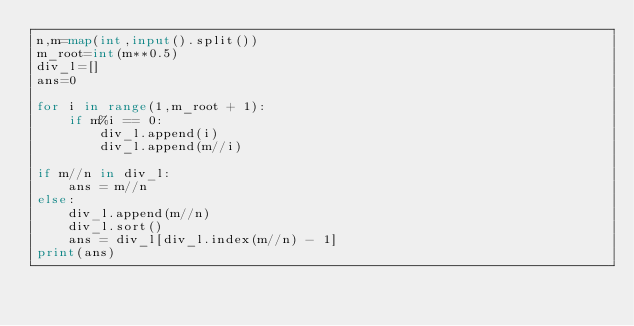Convert code to text. <code><loc_0><loc_0><loc_500><loc_500><_Python_>n,m=map(int,input().split())
m_root=int(m**0.5)
div_l=[]
ans=0

for i in range(1,m_root + 1):
    if m%i == 0:
        div_l.append(i)
        div_l.append(m//i)

if m//n in div_l:
    ans = m//n
else:
    div_l.append(m//n)
    div_l.sort()
    ans = div_l[div_l.index(m//n) - 1]
print(ans)</code> 